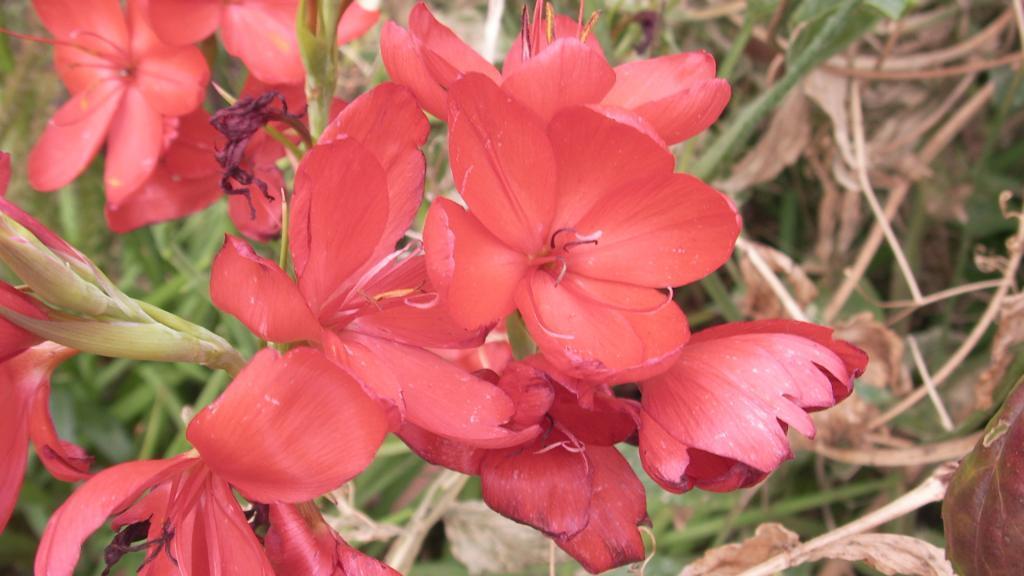Please provide a concise description of this image. In this image I can see few red color flowers and green color leaves. I can see the dry plants. 